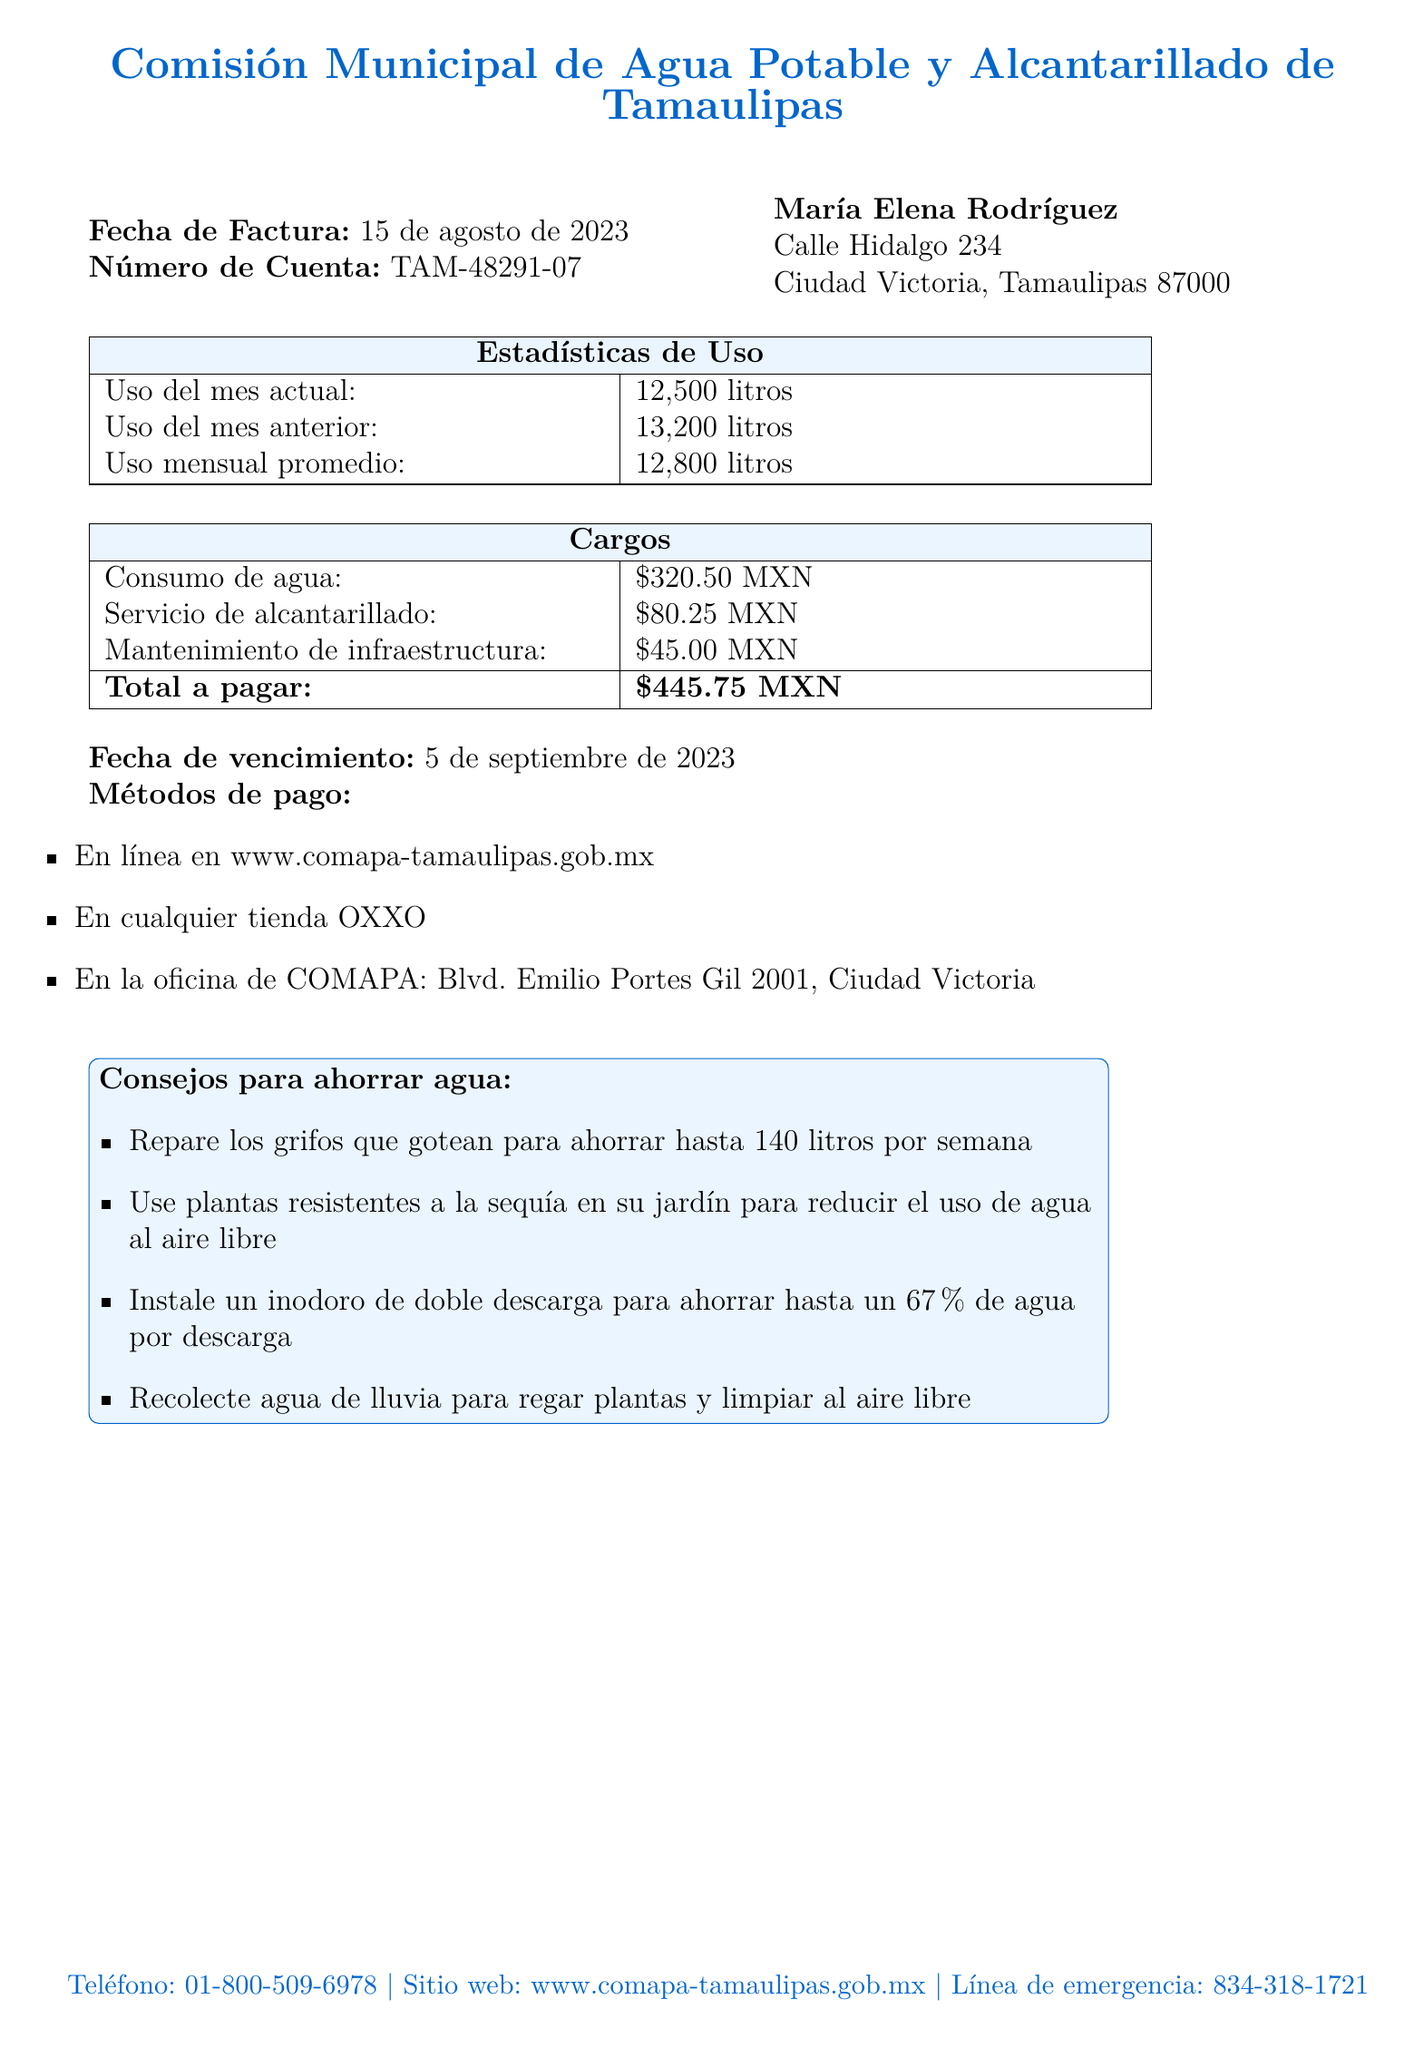¿Qué fue la fecha de la factura? La fecha de la factura se encuentra en la parte superior del documento bajo "Fecha de Factura".
Answer: 15 de agosto de 2023 ¿Cuál es el número de cuenta? El número de cuenta está indicado al lado de "Número de Cuenta".
Answer: TAM-48291-07 ¿Cuánto fue el consumo de agua en el mes actual? El consumo del mes actual se encuentra en la tabla de "Estadísticas de Uso" en el documento.
Answer: 12,500 litros ¿Cuál es el total a pagar? El total a pagar se encuentra en la sección de "Cargos" en la parte inferior de la tabla.
Answer: $445.75 MXN ¿Qué consejos se dan para ahorrar agua? Los consejos se enumeran en la sección de "Consejos para ahorrar agua" y pueden resumen en un breve listado.
Answer: Reparar grifos que gotean, usar plantas resistentes a la sequía, instalar un inodoro de doble descarga, recolectar agua de lluvia ¿Cuál es la fecha de vencimiento de la factura? La fecha de vencimiento está marcada claramente en el documento.
Answer: 5 de septiembre de 2023 ¿Cuál fue el uso mensual promedio? El uso mensual promedio se encuentra en la tabla "Estadísticas de Uso", y se explica en términos de litros.
Answer: 12,800 litros ¿Dónde se puede pagar la factura? Los métodos de pago están indicados en la sección de "Métodos de pago".
Answer: En línea, OXXO, oficina de COMAPA ¿Qué servicio tiene un cargo de $80.25 MXN? Este cargo está especificado en la tabla "Cargos".
Answer: Servicio de alcantarillado 